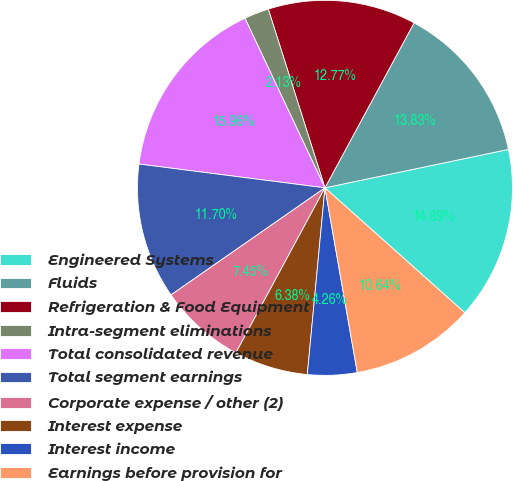Convert chart to OTSL. <chart><loc_0><loc_0><loc_500><loc_500><pie_chart><fcel>Engineered Systems<fcel>Fluids<fcel>Refrigeration & Food Equipment<fcel>Intra-segment eliminations<fcel>Total consolidated revenue<fcel>Total segment earnings<fcel>Corporate expense / other (2)<fcel>Interest expense<fcel>Interest income<fcel>Earnings before provision for<nl><fcel>14.89%<fcel>13.83%<fcel>12.77%<fcel>2.13%<fcel>15.96%<fcel>11.7%<fcel>7.45%<fcel>6.38%<fcel>4.26%<fcel>10.64%<nl></chart> 